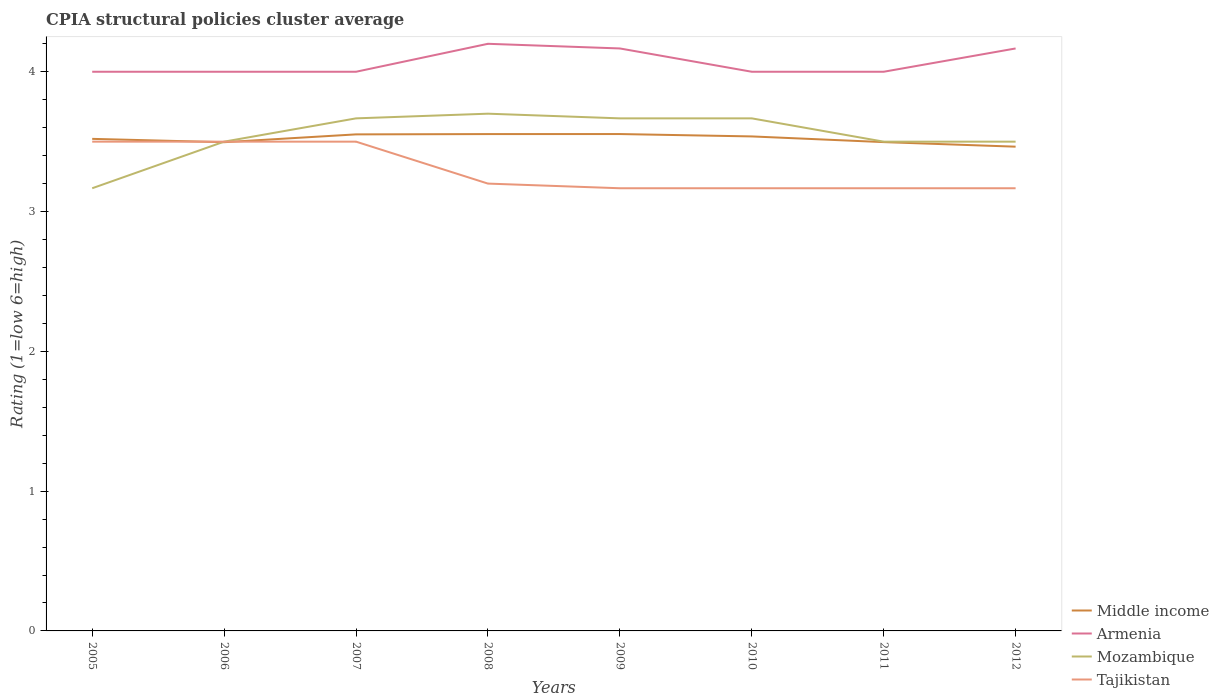Does the line corresponding to Middle income intersect with the line corresponding to Tajikistan?
Provide a short and direct response. Yes. Across all years, what is the maximum CPIA rating in Tajikistan?
Provide a short and direct response. 3.17. In which year was the CPIA rating in Tajikistan maximum?
Ensure brevity in your answer.  2009. What is the total CPIA rating in Tajikistan in the graph?
Offer a very short reply. 0.33. What is the difference between the highest and the second highest CPIA rating in Tajikistan?
Keep it short and to the point. 0.33. What is the difference between the highest and the lowest CPIA rating in Tajikistan?
Make the answer very short. 3. Is the CPIA rating in Tajikistan strictly greater than the CPIA rating in Armenia over the years?
Give a very brief answer. Yes. What is the difference between two consecutive major ticks on the Y-axis?
Provide a short and direct response. 1. Does the graph contain any zero values?
Your response must be concise. No. Does the graph contain grids?
Ensure brevity in your answer.  No. How are the legend labels stacked?
Provide a short and direct response. Vertical. What is the title of the graph?
Offer a very short reply. CPIA structural policies cluster average. What is the label or title of the Y-axis?
Your response must be concise. Rating (1=low 6=high). What is the Rating (1=low 6=high) of Middle income in 2005?
Provide a short and direct response. 3.52. What is the Rating (1=low 6=high) in Mozambique in 2005?
Ensure brevity in your answer.  3.17. What is the Rating (1=low 6=high) in Middle income in 2006?
Your answer should be compact. 3.5. What is the Rating (1=low 6=high) of Mozambique in 2006?
Keep it short and to the point. 3.5. What is the Rating (1=low 6=high) in Tajikistan in 2006?
Provide a succinct answer. 3.5. What is the Rating (1=low 6=high) of Middle income in 2007?
Make the answer very short. 3.55. What is the Rating (1=low 6=high) in Mozambique in 2007?
Keep it short and to the point. 3.67. What is the Rating (1=low 6=high) of Tajikistan in 2007?
Ensure brevity in your answer.  3.5. What is the Rating (1=low 6=high) of Middle income in 2008?
Keep it short and to the point. 3.55. What is the Rating (1=low 6=high) of Armenia in 2008?
Your answer should be compact. 4.2. What is the Rating (1=low 6=high) of Mozambique in 2008?
Offer a terse response. 3.7. What is the Rating (1=low 6=high) in Middle income in 2009?
Offer a terse response. 3.55. What is the Rating (1=low 6=high) in Armenia in 2009?
Make the answer very short. 4.17. What is the Rating (1=low 6=high) in Mozambique in 2009?
Your answer should be compact. 3.67. What is the Rating (1=low 6=high) in Tajikistan in 2009?
Your answer should be very brief. 3.17. What is the Rating (1=low 6=high) of Middle income in 2010?
Offer a terse response. 3.54. What is the Rating (1=low 6=high) in Armenia in 2010?
Your answer should be very brief. 4. What is the Rating (1=low 6=high) of Mozambique in 2010?
Ensure brevity in your answer.  3.67. What is the Rating (1=low 6=high) in Tajikistan in 2010?
Offer a very short reply. 3.17. What is the Rating (1=low 6=high) in Middle income in 2011?
Your response must be concise. 3.5. What is the Rating (1=low 6=high) of Tajikistan in 2011?
Your answer should be compact. 3.17. What is the Rating (1=low 6=high) in Middle income in 2012?
Provide a short and direct response. 3.46. What is the Rating (1=low 6=high) of Armenia in 2012?
Provide a short and direct response. 4.17. What is the Rating (1=low 6=high) of Mozambique in 2012?
Provide a succinct answer. 3.5. What is the Rating (1=low 6=high) of Tajikistan in 2012?
Keep it short and to the point. 3.17. Across all years, what is the maximum Rating (1=low 6=high) in Middle income?
Your answer should be compact. 3.55. Across all years, what is the maximum Rating (1=low 6=high) of Armenia?
Your response must be concise. 4.2. Across all years, what is the minimum Rating (1=low 6=high) of Middle income?
Your answer should be very brief. 3.46. Across all years, what is the minimum Rating (1=low 6=high) in Armenia?
Ensure brevity in your answer.  4. Across all years, what is the minimum Rating (1=low 6=high) in Mozambique?
Your answer should be very brief. 3.17. Across all years, what is the minimum Rating (1=low 6=high) of Tajikistan?
Provide a succinct answer. 3.17. What is the total Rating (1=low 6=high) of Middle income in the graph?
Ensure brevity in your answer.  28.17. What is the total Rating (1=low 6=high) of Armenia in the graph?
Offer a terse response. 32.53. What is the total Rating (1=low 6=high) of Mozambique in the graph?
Give a very brief answer. 28.37. What is the total Rating (1=low 6=high) in Tajikistan in the graph?
Your response must be concise. 26.37. What is the difference between the Rating (1=low 6=high) of Middle income in 2005 and that in 2006?
Your answer should be very brief. 0.02. What is the difference between the Rating (1=low 6=high) in Mozambique in 2005 and that in 2006?
Make the answer very short. -0.33. What is the difference between the Rating (1=low 6=high) in Middle income in 2005 and that in 2007?
Make the answer very short. -0.03. What is the difference between the Rating (1=low 6=high) of Middle income in 2005 and that in 2008?
Your answer should be very brief. -0.03. What is the difference between the Rating (1=low 6=high) in Mozambique in 2005 and that in 2008?
Keep it short and to the point. -0.53. What is the difference between the Rating (1=low 6=high) of Tajikistan in 2005 and that in 2008?
Offer a terse response. 0.3. What is the difference between the Rating (1=low 6=high) in Middle income in 2005 and that in 2009?
Keep it short and to the point. -0.03. What is the difference between the Rating (1=low 6=high) in Armenia in 2005 and that in 2009?
Provide a succinct answer. -0.17. What is the difference between the Rating (1=low 6=high) of Mozambique in 2005 and that in 2009?
Offer a terse response. -0.5. What is the difference between the Rating (1=low 6=high) of Tajikistan in 2005 and that in 2009?
Offer a terse response. 0.33. What is the difference between the Rating (1=low 6=high) in Middle income in 2005 and that in 2010?
Ensure brevity in your answer.  -0.02. What is the difference between the Rating (1=low 6=high) in Armenia in 2005 and that in 2010?
Offer a very short reply. 0. What is the difference between the Rating (1=low 6=high) of Tajikistan in 2005 and that in 2010?
Provide a succinct answer. 0.33. What is the difference between the Rating (1=low 6=high) in Middle income in 2005 and that in 2011?
Provide a short and direct response. 0.02. What is the difference between the Rating (1=low 6=high) of Mozambique in 2005 and that in 2011?
Offer a terse response. -0.33. What is the difference between the Rating (1=low 6=high) of Middle income in 2005 and that in 2012?
Your response must be concise. 0.06. What is the difference between the Rating (1=low 6=high) of Middle income in 2006 and that in 2007?
Your response must be concise. -0.06. What is the difference between the Rating (1=low 6=high) of Armenia in 2006 and that in 2007?
Your response must be concise. 0. What is the difference between the Rating (1=low 6=high) in Middle income in 2006 and that in 2008?
Provide a short and direct response. -0.06. What is the difference between the Rating (1=low 6=high) of Armenia in 2006 and that in 2008?
Provide a short and direct response. -0.2. What is the difference between the Rating (1=low 6=high) in Mozambique in 2006 and that in 2008?
Ensure brevity in your answer.  -0.2. What is the difference between the Rating (1=low 6=high) of Tajikistan in 2006 and that in 2008?
Your response must be concise. 0.3. What is the difference between the Rating (1=low 6=high) in Middle income in 2006 and that in 2009?
Keep it short and to the point. -0.06. What is the difference between the Rating (1=low 6=high) of Armenia in 2006 and that in 2009?
Offer a terse response. -0.17. What is the difference between the Rating (1=low 6=high) of Mozambique in 2006 and that in 2009?
Provide a succinct answer. -0.17. What is the difference between the Rating (1=low 6=high) in Middle income in 2006 and that in 2010?
Provide a short and direct response. -0.04. What is the difference between the Rating (1=low 6=high) of Armenia in 2006 and that in 2010?
Provide a succinct answer. 0. What is the difference between the Rating (1=low 6=high) of Tajikistan in 2006 and that in 2010?
Provide a succinct answer. 0.33. What is the difference between the Rating (1=low 6=high) in Middle income in 2006 and that in 2011?
Offer a very short reply. -0. What is the difference between the Rating (1=low 6=high) of Middle income in 2006 and that in 2012?
Give a very brief answer. 0.03. What is the difference between the Rating (1=low 6=high) of Armenia in 2006 and that in 2012?
Your answer should be compact. -0.17. What is the difference between the Rating (1=low 6=high) of Mozambique in 2006 and that in 2012?
Your answer should be compact. 0. What is the difference between the Rating (1=low 6=high) of Tajikistan in 2006 and that in 2012?
Your response must be concise. 0.33. What is the difference between the Rating (1=low 6=high) in Middle income in 2007 and that in 2008?
Make the answer very short. -0. What is the difference between the Rating (1=low 6=high) of Armenia in 2007 and that in 2008?
Keep it short and to the point. -0.2. What is the difference between the Rating (1=low 6=high) in Mozambique in 2007 and that in 2008?
Make the answer very short. -0.03. What is the difference between the Rating (1=low 6=high) in Tajikistan in 2007 and that in 2008?
Your answer should be very brief. 0.3. What is the difference between the Rating (1=low 6=high) of Middle income in 2007 and that in 2009?
Make the answer very short. -0. What is the difference between the Rating (1=low 6=high) in Armenia in 2007 and that in 2009?
Your response must be concise. -0.17. What is the difference between the Rating (1=low 6=high) of Tajikistan in 2007 and that in 2009?
Ensure brevity in your answer.  0.33. What is the difference between the Rating (1=low 6=high) of Middle income in 2007 and that in 2010?
Your answer should be compact. 0.01. What is the difference between the Rating (1=low 6=high) in Armenia in 2007 and that in 2010?
Give a very brief answer. 0. What is the difference between the Rating (1=low 6=high) of Mozambique in 2007 and that in 2010?
Your answer should be very brief. 0. What is the difference between the Rating (1=low 6=high) in Middle income in 2007 and that in 2011?
Offer a very short reply. 0.06. What is the difference between the Rating (1=low 6=high) in Tajikistan in 2007 and that in 2011?
Make the answer very short. 0.33. What is the difference between the Rating (1=low 6=high) of Middle income in 2007 and that in 2012?
Your response must be concise. 0.09. What is the difference between the Rating (1=low 6=high) in Armenia in 2007 and that in 2012?
Your response must be concise. -0.17. What is the difference between the Rating (1=low 6=high) of Tajikistan in 2007 and that in 2012?
Ensure brevity in your answer.  0.33. What is the difference between the Rating (1=low 6=high) in Middle income in 2008 and that in 2009?
Give a very brief answer. -0. What is the difference between the Rating (1=low 6=high) in Armenia in 2008 and that in 2009?
Make the answer very short. 0.03. What is the difference between the Rating (1=low 6=high) in Mozambique in 2008 and that in 2009?
Ensure brevity in your answer.  0.03. What is the difference between the Rating (1=low 6=high) of Middle income in 2008 and that in 2010?
Provide a short and direct response. 0.02. What is the difference between the Rating (1=low 6=high) of Armenia in 2008 and that in 2010?
Offer a very short reply. 0.2. What is the difference between the Rating (1=low 6=high) of Mozambique in 2008 and that in 2010?
Offer a very short reply. 0.03. What is the difference between the Rating (1=low 6=high) of Middle income in 2008 and that in 2011?
Provide a short and direct response. 0.06. What is the difference between the Rating (1=low 6=high) in Middle income in 2008 and that in 2012?
Give a very brief answer. 0.09. What is the difference between the Rating (1=low 6=high) of Tajikistan in 2008 and that in 2012?
Provide a succinct answer. 0.03. What is the difference between the Rating (1=low 6=high) in Middle income in 2009 and that in 2010?
Keep it short and to the point. 0.02. What is the difference between the Rating (1=low 6=high) of Mozambique in 2009 and that in 2010?
Give a very brief answer. 0. What is the difference between the Rating (1=low 6=high) in Middle income in 2009 and that in 2011?
Make the answer very short. 0.06. What is the difference between the Rating (1=low 6=high) in Mozambique in 2009 and that in 2011?
Keep it short and to the point. 0.17. What is the difference between the Rating (1=low 6=high) in Tajikistan in 2009 and that in 2011?
Your answer should be compact. 0. What is the difference between the Rating (1=low 6=high) in Middle income in 2009 and that in 2012?
Your response must be concise. 0.09. What is the difference between the Rating (1=low 6=high) of Armenia in 2009 and that in 2012?
Your answer should be very brief. 0. What is the difference between the Rating (1=low 6=high) of Tajikistan in 2009 and that in 2012?
Keep it short and to the point. 0. What is the difference between the Rating (1=low 6=high) of Middle income in 2010 and that in 2011?
Your response must be concise. 0.04. What is the difference between the Rating (1=low 6=high) of Armenia in 2010 and that in 2011?
Ensure brevity in your answer.  0. What is the difference between the Rating (1=low 6=high) of Mozambique in 2010 and that in 2011?
Make the answer very short. 0.17. What is the difference between the Rating (1=low 6=high) of Tajikistan in 2010 and that in 2011?
Give a very brief answer. 0. What is the difference between the Rating (1=low 6=high) of Middle income in 2010 and that in 2012?
Your response must be concise. 0.07. What is the difference between the Rating (1=low 6=high) in Mozambique in 2010 and that in 2012?
Ensure brevity in your answer.  0.17. What is the difference between the Rating (1=low 6=high) in Middle income in 2011 and that in 2012?
Provide a short and direct response. 0.03. What is the difference between the Rating (1=low 6=high) in Tajikistan in 2011 and that in 2012?
Your response must be concise. 0. What is the difference between the Rating (1=low 6=high) of Middle income in 2005 and the Rating (1=low 6=high) of Armenia in 2006?
Give a very brief answer. -0.48. What is the difference between the Rating (1=low 6=high) of Middle income in 2005 and the Rating (1=low 6=high) of Mozambique in 2006?
Make the answer very short. 0.02. What is the difference between the Rating (1=low 6=high) in Middle income in 2005 and the Rating (1=low 6=high) in Tajikistan in 2006?
Provide a short and direct response. 0.02. What is the difference between the Rating (1=low 6=high) in Armenia in 2005 and the Rating (1=low 6=high) in Mozambique in 2006?
Your answer should be compact. 0.5. What is the difference between the Rating (1=low 6=high) in Middle income in 2005 and the Rating (1=low 6=high) in Armenia in 2007?
Provide a succinct answer. -0.48. What is the difference between the Rating (1=low 6=high) of Middle income in 2005 and the Rating (1=low 6=high) of Mozambique in 2007?
Offer a terse response. -0.15. What is the difference between the Rating (1=low 6=high) of Armenia in 2005 and the Rating (1=low 6=high) of Mozambique in 2007?
Provide a short and direct response. 0.33. What is the difference between the Rating (1=low 6=high) of Mozambique in 2005 and the Rating (1=low 6=high) of Tajikistan in 2007?
Provide a short and direct response. -0.33. What is the difference between the Rating (1=low 6=high) in Middle income in 2005 and the Rating (1=low 6=high) in Armenia in 2008?
Your response must be concise. -0.68. What is the difference between the Rating (1=low 6=high) of Middle income in 2005 and the Rating (1=low 6=high) of Mozambique in 2008?
Your answer should be very brief. -0.18. What is the difference between the Rating (1=low 6=high) of Middle income in 2005 and the Rating (1=low 6=high) of Tajikistan in 2008?
Offer a very short reply. 0.32. What is the difference between the Rating (1=low 6=high) in Armenia in 2005 and the Rating (1=low 6=high) in Mozambique in 2008?
Your answer should be compact. 0.3. What is the difference between the Rating (1=low 6=high) of Armenia in 2005 and the Rating (1=low 6=high) of Tajikistan in 2008?
Give a very brief answer. 0.8. What is the difference between the Rating (1=low 6=high) in Mozambique in 2005 and the Rating (1=low 6=high) in Tajikistan in 2008?
Provide a succinct answer. -0.03. What is the difference between the Rating (1=low 6=high) in Middle income in 2005 and the Rating (1=low 6=high) in Armenia in 2009?
Provide a short and direct response. -0.65. What is the difference between the Rating (1=low 6=high) in Middle income in 2005 and the Rating (1=low 6=high) in Mozambique in 2009?
Give a very brief answer. -0.15. What is the difference between the Rating (1=low 6=high) in Middle income in 2005 and the Rating (1=low 6=high) in Tajikistan in 2009?
Your response must be concise. 0.35. What is the difference between the Rating (1=low 6=high) in Armenia in 2005 and the Rating (1=low 6=high) in Mozambique in 2009?
Offer a terse response. 0.33. What is the difference between the Rating (1=low 6=high) of Middle income in 2005 and the Rating (1=low 6=high) of Armenia in 2010?
Your answer should be compact. -0.48. What is the difference between the Rating (1=low 6=high) of Middle income in 2005 and the Rating (1=low 6=high) of Mozambique in 2010?
Provide a succinct answer. -0.15. What is the difference between the Rating (1=low 6=high) of Middle income in 2005 and the Rating (1=low 6=high) of Tajikistan in 2010?
Your answer should be compact. 0.35. What is the difference between the Rating (1=low 6=high) of Armenia in 2005 and the Rating (1=low 6=high) of Mozambique in 2010?
Keep it short and to the point. 0.33. What is the difference between the Rating (1=low 6=high) in Armenia in 2005 and the Rating (1=low 6=high) in Tajikistan in 2010?
Keep it short and to the point. 0.83. What is the difference between the Rating (1=low 6=high) of Middle income in 2005 and the Rating (1=low 6=high) of Armenia in 2011?
Provide a short and direct response. -0.48. What is the difference between the Rating (1=low 6=high) in Middle income in 2005 and the Rating (1=low 6=high) in Tajikistan in 2011?
Ensure brevity in your answer.  0.35. What is the difference between the Rating (1=low 6=high) in Mozambique in 2005 and the Rating (1=low 6=high) in Tajikistan in 2011?
Provide a short and direct response. 0. What is the difference between the Rating (1=low 6=high) in Middle income in 2005 and the Rating (1=low 6=high) in Armenia in 2012?
Your answer should be very brief. -0.65. What is the difference between the Rating (1=low 6=high) in Middle income in 2005 and the Rating (1=low 6=high) in Mozambique in 2012?
Ensure brevity in your answer.  0.02. What is the difference between the Rating (1=low 6=high) of Middle income in 2005 and the Rating (1=low 6=high) of Tajikistan in 2012?
Make the answer very short. 0.35. What is the difference between the Rating (1=low 6=high) in Armenia in 2005 and the Rating (1=low 6=high) in Tajikistan in 2012?
Give a very brief answer. 0.83. What is the difference between the Rating (1=low 6=high) in Middle income in 2006 and the Rating (1=low 6=high) in Armenia in 2007?
Make the answer very short. -0.5. What is the difference between the Rating (1=low 6=high) of Middle income in 2006 and the Rating (1=low 6=high) of Mozambique in 2007?
Offer a very short reply. -0.17. What is the difference between the Rating (1=low 6=high) in Middle income in 2006 and the Rating (1=low 6=high) in Tajikistan in 2007?
Offer a terse response. -0. What is the difference between the Rating (1=low 6=high) of Mozambique in 2006 and the Rating (1=low 6=high) of Tajikistan in 2007?
Offer a very short reply. 0. What is the difference between the Rating (1=low 6=high) in Middle income in 2006 and the Rating (1=low 6=high) in Armenia in 2008?
Provide a short and direct response. -0.7. What is the difference between the Rating (1=low 6=high) in Middle income in 2006 and the Rating (1=low 6=high) in Mozambique in 2008?
Offer a very short reply. -0.2. What is the difference between the Rating (1=low 6=high) in Middle income in 2006 and the Rating (1=low 6=high) in Tajikistan in 2008?
Your answer should be very brief. 0.3. What is the difference between the Rating (1=low 6=high) in Armenia in 2006 and the Rating (1=low 6=high) in Tajikistan in 2008?
Your answer should be compact. 0.8. What is the difference between the Rating (1=low 6=high) in Middle income in 2006 and the Rating (1=low 6=high) in Armenia in 2009?
Your response must be concise. -0.67. What is the difference between the Rating (1=low 6=high) in Middle income in 2006 and the Rating (1=low 6=high) in Mozambique in 2009?
Your answer should be compact. -0.17. What is the difference between the Rating (1=low 6=high) of Middle income in 2006 and the Rating (1=low 6=high) of Tajikistan in 2009?
Give a very brief answer. 0.33. What is the difference between the Rating (1=low 6=high) in Middle income in 2006 and the Rating (1=low 6=high) in Armenia in 2010?
Give a very brief answer. -0.5. What is the difference between the Rating (1=low 6=high) in Middle income in 2006 and the Rating (1=low 6=high) in Mozambique in 2010?
Offer a terse response. -0.17. What is the difference between the Rating (1=low 6=high) in Middle income in 2006 and the Rating (1=low 6=high) in Tajikistan in 2010?
Your answer should be compact. 0.33. What is the difference between the Rating (1=low 6=high) in Armenia in 2006 and the Rating (1=low 6=high) in Mozambique in 2010?
Your response must be concise. 0.33. What is the difference between the Rating (1=low 6=high) of Mozambique in 2006 and the Rating (1=low 6=high) of Tajikistan in 2010?
Offer a terse response. 0.33. What is the difference between the Rating (1=low 6=high) of Middle income in 2006 and the Rating (1=low 6=high) of Armenia in 2011?
Your answer should be compact. -0.5. What is the difference between the Rating (1=low 6=high) in Middle income in 2006 and the Rating (1=low 6=high) in Mozambique in 2011?
Give a very brief answer. -0. What is the difference between the Rating (1=low 6=high) of Middle income in 2006 and the Rating (1=low 6=high) of Tajikistan in 2011?
Ensure brevity in your answer.  0.33. What is the difference between the Rating (1=low 6=high) of Armenia in 2006 and the Rating (1=low 6=high) of Mozambique in 2011?
Your response must be concise. 0.5. What is the difference between the Rating (1=low 6=high) in Mozambique in 2006 and the Rating (1=low 6=high) in Tajikistan in 2011?
Offer a terse response. 0.33. What is the difference between the Rating (1=low 6=high) in Middle income in 2006 and the Rating (1=low 6=high) in Armenia in 2012?
Make the answer very short. -0.67. What is the difference between the Rating (1=low 6=high) of Middle income in 2006 and the Rating (1=low 6=high) of Mozambique in 2012?
Provide a short and direct response. -0. What is the difference between the Rating (1=low 6=high) in Middle income in 2006 and the Rating (1=low 6=high) in Tajikistan in 2012?
Ensure brevity in your answer.  0.33. What is the difference between the Rating (1=low 6=high) in Armenia in 2006 and the Rating (1=low 6=high) in Mozambique in 2012?
Your response must be concise. 0.5. What is the difference between the Rating (1=low 6=high) in Armenia in 2006 and the Rating (1=low 6=high) in Tajikistan in 2012?
Offer a very short reply. 0.83. What is the difference between the Rating (1=low 6=high) of Middle income in 2007 and the Rating (1=low 6=high) of Armenia in 2008?
Provide a short and direct response. -0.65. What is the difference between the Rating (1=low 6=high) in Middle income in 2007 and the Rating (1=low 6=high) in Mozambique in 2008?
Make the answer very short. -0.15. What is the difference between the Rating (1=low 6=high) of Middle income in 2007 and the Rating (1=low 6=high) of Tajikistan in 2008?
Ensure brevity in your answer.  0.35. What is the difference between the Rating (1=low 6=high) in Armenia in 2007 and the Rating (1=low 6=high) in Tajikistan in 2008?
Your response must be concise. 0.8. What is the difference between the Rating (1=low 6=high) of Mozambique in 2007 and the Rating (1=low 6=high) of Tajikistan in 2008?
Your answer should be very brief. 0.47. What is the difference between the Rating (1=low 6=high) in Middle income in 2007 and the Rating (1=low 6=high) in Armenia in 2009?
Provide a succinct answer. -0.61. What is the difference between the Rating (1=low 6=high) of Middle income in 2007 and the Rating (1=low 6=high) of Mozambique in 2009?
Your answer should be very brief. -0.11. What is the difference between the Rating (1=low 6=high) of Middle income in 2007 and the Rating (1=low 6=high) of Tajikistan in 2009?
Your response must be concise. 0.39. What is the difference between the Rating (1=low 6=high) in Armenia in 2007 and the Rating (1=low 6=high) in Mozambique in 2009?
Make the answer very short. 0.33. What is the difference between the Rating (1=low 6=high) in Middle income in 2007 and the Rating (1=low 6=high) in Armenia in 2010?
Give a very brief answer. -0.45. What is the difference between the Rating (1=low 6=high) of Middle income in 2007 and the Rating (1=low 6=high) of Mozambique in 2010?
Give a very brief answer. -0.11. What is the difference between the Rating (1=low 6=high) of Middle income in 2007 and the Rating (1=low 6=high) of Tajikistan in 2010?
Offer a very short reply. 0.39. What is the difference between the Rating (1=low 6=high) in Middle income in 2007 and the Rating (1=low 6=high) in Armenia in 2011?
Keep it short and to the point. -0.45. What is the difference between the Rating (1=low 6=high) in Middle income in 2007 and the Rating (1=low 6=high) in Mozambique in 2011?
Your answer should be compact. 0.05. What is the difference between the Rating (1=low 6=high) of Middle income in 2007 and the Rating (1=low 6=high) of Tajikistan in 2011?
Keep it short and to the point. 0.39. What is the difference between the Rating (1=low 6=high) of Armenia in 2007 and the Rating (1=low 6=high) of Mozambique in 2011?
Give a very brief answer. 0.5. What is the difference between the Rating (1=low 6=high) in Middle income in 2007 and the Rating (1=low 6=high) in Armenia in 2012?
Your answer should be very brief. -0.61. What is the difference between the Rating (1=low 6=high) of Middle income in 2007 and the Rating (1=low 6=high) of Mozambique in 2012?
Offer a very short reply. 0.05. What is the difference between the Rating (1=low 6=high) of Middle income in 2007 and the Rating (1=low 6=high) of Tajikistan in 2012?
Keep it short and to the point. 0.39. What is the difference between the Rating (1=low 6=high) in Mozambique in 2007 and the Rating (1=low 6=high) in Tajikistan in 2012?
Provide a short and direct response. 0.5. What is the difference between the Rating (1=low 6=high) in Middle income in 2008 and the Rating (1=low 6=high) in Armenia in 2009?
Give a very brief answer. -0.61. What is the difference between the Rating (1=low 6=high) of Middle income in 2008 and the Rating (1=low 6=high) of Mozambique in 2009?
Your response must be concise. -0.11. What is the difference between the Rating (1=low 6=high) of Middle income in 2008 and the Rating (1=low 6=high) of Tajikistan in 2009?
Offer a terse response. 0.39. What is the difference between the Rating (1=low 6=high) in Armenia in 2008 and the Rating (1=low 6=high) in Mozambique in 2009?
Your answer should be compact. 0.53. What is the difference between the Rating (1=low 6=high) in Mozambique in 2008 and the Rating (1=low 6=high) in Tajikistan in 2009?
Your response must be concise. 0.53. What is the difference between the Rating (1=low 6=high) of Middle income in 2008 and the Rating (1=low 6=high) of Armenia in 2010?
Ensure brevity in your answer.  -0.45. What is the difference between the Rating (1=low 6=high) in Middle income in 2008 and the Rating (1=low 6=high) in Mozambique in 2010?
Make the answer very short. -0.11. What is the difference between the Rating (1=low 6=high) in Middle income in 2008 and the Rating (1=low 6=high) in Tajikistan in 2010?
Your answer should be compact. 0.39. What is the difference between the Rating (1=low 6=high) in Armenia in 2008 and the Rating (1=low 6=high) in Mozambique in 2010?
Make the answer very short. 0.53. What is the difference between the Rating (1=low 6=high) of Armenia in 2008 and the Rating (1=low 6=high) of Tajikistan in 2010?
Your answer should be compact. 1.03. What is the difference between the Rating (1=low 6=high) of Mozambique in 2008 and the Rating (1=low 6=high) of Tajikistan in 2010?
Give a very brief answer. 0.53. What is the difference between the Rating (1=low 6=high) in Middle income in 2008 and the Rating (1=low 6=high) in Armenia in 2011?
Provide a succinct answer. -0.45. What is the difference between the Rating (1=low 6=high) in Middle income in 2008 and the Rating (1=low 6=high) in Mozambique in 2011?
Offer a terse response. 0.05. What is the difference between the Rating (1=low 6=high) of Middle income in 2008 and the Rating (1=low 6=high) of Tajikistan in 2011?
Provide a succinct answer. 0.39. What is the difference between the Rating (1=low 6=high) of Mozambique in 2008 and the Rating (1=low 6=high) of Tajikistan in 2011?
Your response must be concise. 0.53. What is the difference between the Rating (1=low 6=high) in Middle income in 2008 and the Rating (1=low 6=high) in Armenia in 2012?
Your answer should be compact. -0.61. What is the difference between the Rating (1=low 6=high) in Middle income in 2008 and the Rating (1=low 6=high) in Mozambique in 2012?
Keep it short and to the point. 0.05. What is the difference between the Rating (1=low 6=high) of Middle income in 2008 and the Rating (1=low 6=high) of Tajikistan in 2012?
Your answer should be very brief. 0.39. What is the difference between the Rating (1=low 6=high) of Armenia in 2008 and the Rating (1=low 6=high) of Mozambique in 2012?
Offer a terse response. 0.7. What is the difference between the Rating (1=low 6=high) of Armenia in 2008 and the Rating (1=low 6=high) of Tajikistan in 2012?
Offer a very short reply. 1.03. What is the difference between the Rating (1=low 6=high) of Mozambique in 2008 and the Rating (1=low 6=high) of Tajikistan in 2012?
Your answer should be compact. 0.53. What is the difference between the Rating (1=low 6=high) of Middle income in 2009 and the Rating (1=low 6=high) of Armenia in 2010?
Your answer should be very brief. -0.45. What is the difference between the Rating (1=low 6=high) of Middle income in 2009 and the Rating (1=low 6=high) of Mozambique in 2010?
Provide a succinct answer. -0.11. What is the difference between the Rating (1=low 6=high) in Middle income in 2009 and the Rating (1=low 6=high) in Tajikistan in 2010?
Provide a short and direct response. 0.39. What is the difference between the Rating (1=low 6=high) in Armenia in 2009 and the Rating (1=low 6=high) in Tajikistan in 2010?
Give a very brief answer. 1. What is the difference between the Rating (1=low 6=high) in Mozambique in 2009 and the Rating (1=low 6=high) in Tajikistan in 2010?
Provide a succinct answer. 0.5. What is the difference between the Rating (1=low 6=high) in Middle income in 2009 and the Rating (1=low 6=high) in Armenia in 2011?
Make the answer very short. -0.45. What is the difference between the Rating (1=low 6=high) of Middle income in 2009 and the Rating (1=low 6=high) of Mozambique in 2011?
Give a very brief answer. 0.05. What is the difference between the Rating (1=low 6=high) of Middle income in 2009 and the Rating (1=low 6=high) of Tajikistan in 2011?
Keep it short and to the point. 0.39. What is the difference between the Rating (1=low 6=high) of Armenia in 2009 and the Rating (1=low 6=high) of Mozambique in 2011?
Keep it short and to the point. 0.67. What is the difference between the Rating (1=low 6=high) in Mozambique in 2009 and the Rating (1=low 6=high) in Tajikistan in 2011?
Ensure brevity in your answer.  0.5. What is the difference between the Rating (1=low 6=high) in Middle income in 2009 and the Rating (1=low 6=high) in Armenia in 2012?
Keep it short and to the point. -0.61. What is the difference between the Rating (1=low 6=high) in Middle income in 2009 and the Rating (1=low 6=high) in Mozambique in 2012?
Ensure brevity in your answer.  0.05. What is the difference between the Rating (1=low 6=high) in Middle income in 2009 and the Rating (1=low 6=high) in Tajikistan in 2012?
Make the answer very short. 0.39. What is the difference between the Rating (1=low 6=high) of Mozambique in 2009 and the Rating (1=low 6=high) of Tajikistan in 2012?
Give a very brief answer. 0.5. What is the difference between the Rating (1=low 6=high) in Middle income in 2010 and the Rating (1=low 6=high) in Armenia in 2011?
Provide a succinct answer. -0.46. What is the difference between the Rating (1=low 6=high) in Middle income in 2010 and the Rating (1=low 6=high) in Mozambique in 2011?
Your response must be concise. 0.04. What is the difference between the Rating (1=low 6=high) in Middle income in 2010 and the Rating (1=low 6=high) in Tajikistan in 2011?
Your answer should be compact. 0.37. What is the difference between the Rating (1=low 6=high) of Mozambique in 2010 and the Rating (1=low 6=high) of Tajikistan in 2011?
Provide a short and direct response. 0.5. What is the difference between the Rating (1=low 6=high) in Middle income in 2010 and the Rating (1=low 6=high) in Armenia in 2012?
Keep it short and to the point. -0.63. What is the difference between the Rating (1=low 6=high) of Middle income in 2010 and the Rating (1=low 6=high) of Mozambique in 2012?
Provide a succinct answer. 0.04. What is the difference between the Rating (1=low 6=high) of Middle income in 2010 and the Rating (1=low 6=high) of Tajikistan in 2012?
Give a very brief answer. 0.37. What is the difference between the Rating (1=low 6=high) in Armenia in 2010 and the Rating (1=low 6=high) in Tajikistan in 2012?
Your answer should be very brief. 0.83. What is the difference between the Rating (1=low 6=high) of Mozambique in 2010 and the Rating (1=low 6=high) of Tajikistan in 2012?
Your response must be concise. 0.5. What is the difference between the Rating (1=low 6=high) of Middle income in 2011 and the Rating (1=low 6=high) of Armenia in 2012?
Make the answer very short. -0.67. What is the difference between the Rating (1=low 6=high) in Middle income in 2011 and the Rating (1=low 6=high) in Mozambique in 2012?
Your response must be concise. -0. What is the difference between the Rating (1=low 6=high) in Middle income in 2011 and the Rating (1=low 6=high) in Tajikistan in 2012?
Your answer should be compact. 0.33. What is the difference between the Rating (1=low 6=high) of Armenia in 2011 and the Rating (1=low 6=high) of Mozambique in 2012?
Provide a short and direct response. 0.5. What is the difference between the Rating (1=low 6=high) of Mozambique in 2011 and the Rating (1=low 6=high) of Tajikistan in 2012?
Offer a very short reply. 0.33. What is the average Rating (1=low 6=high) in Middle income per year?
Provide a succinct answer. 3.52. What is the average Rating (1=low 6=high) in Armenia per year?
Ensure brevity in your answer.  4.07. What is the average Rating (1=low 6=high) of Mozambique per year?
Provide a succinct answer. 3.55. What is the average Rating (1=low 6=high) of Tajikistan per year?
Offer a terse response. 3.3. In the year 2005, what is the difference between the Rating (1=low 6=high) in Middle income and Rating (1=low 6=high) in Armenia?
Offer a very short reply. -0.48. In the year 2005, what is the difference between the Rating (1=low 6=high) in Middle income and Rating (1=low 6=high) in Mozambique?
Offer a terse response. 0.35. In the year 2005, what is the difference between the Rating (1=low 6=high) in Middle income and Rating (1=low 6=high) in Tajikistan?
Your response must be concise. 0.02. In the year 2005, what is the difference between the Rating (1=low 6=high) of Armenia and Rating (1=low 6=high) of Tajikistan?
Provide a succinct answer. 0.5. In the year 2006, what is the difference between the Rating (1=low 6=high) in Middle income and Rating (1=low 6=high) in Armenia?
Offer a very short reply. -0.5. In the year 2006, what is the difference between the Rating (1=low 6=high) in Middle income and Rating (1=low 6=high) in Mozambique?
Provide a short and direct response. -0. In the year 2006, what is the difference between the Rating (1=low 6=high) in Middle income and Rating (1=low 6=high) in Tajikistan?
Ensure brevity in your answer.  -0. In the year 2006, what is the difference between the Rating (1=low 6=high) of Armenia and Rating (1=low 6=high) of Tajikistan?
Provide a short and direct response. 0.5. In the year 2006, what is the difference between the Rating (1=low 6=high) of Mozambique and Rating (1=low 6=high) of Tajikistan?
Offer a very short reply. 0. In the year 2007, what is the difference between the Rating (1=low 6=high) in Middle income and Rating (1=low 6=high) in Armenia?
Ensure brevity in your answer.  -0.45. In the year 2007, what is the difference between the Rating (1=low 6=high) of Middle income and Rating (1=low 6=high) of Mozambique?
Keep it short and to the point. -0.11. In the year 2007, what is the difference between the Rating (1=low 6=high) in Middle income and Rating (1=low 6=high) in Tajikistan?
Provide a short and direct response. 0.05. In the year 2007, what is the difference between the Rating (1=low 6=high) in Armenia and Rating (1=low 6=high) in Tajikistan?
Keep it short and to the point. 0.5. In the year 2008, what is the difference between the Rating (1=low 6=high) in Middle income and Rating (1=low 6=high) in Armenia?
Ensure brevity in your answer.  -0.65. In the year 2008, what is the difference between the Rating (1=low 6=high) of Middle income and Rating (1=low 6=high) of Mozambique?
Give a very brief answer. -0.15. In the year 2008, what is the difference between the Rating (1=low 6=high) in Middle income and Rating (1=low 6=high) in Tajikistan?
Offer a terse response. 0.35. In the year 2008, what is the difference between the Rating (1=low 6=high) in Mozambique and Rating (1=low 6=high) in Tajikistan?
Make the answer very short. 0.5. In the year 2009, what is the difference between the Rating (1=low 6=high) of Middle income and Rating (1=low 6=high) of Armenia?
Keep it short and to the point. -0.61. In the year 2009, what is the difference between the Rating (1=low 6=high) of Middle income and Rating (1=low 6=high) of Mozambique?
Your answer should be very brief. -0.11. In the year 2009, what is the difference between the Rating (1=low 6=high) of Middle income and Rating (1=low 6=high) of Tajikistan?
Make the answer very short. 0.39. In the year 2009, what is the difference between the Rating (1=low 6=high) in Armenia and Rating (1=low 6=high) in Tajikistan?
Provide a succinct answer. 1. In the year 2009, what is the difference between the Rating (1=low 6=high) in Mozambique and Rating (1=low 6=high) in Tajikistan?
Ensure brevity in your answer.  0.5. In the year 2010, what is the difference between the Rating (1=low 6=high) of Middle income and Rating (1=low 6=high) of Armenia?
Offer a very short reply. -0.46. In the year 2010, what is the difference between the Rating (1=low 6=high) of Middle income and Rating (1=low 6=high) of Mozambique?
Provide a short and direct response. -0.13. In the year 2010, what is the difference between the Rating (1=low 6=high) of Middle income and Rating (1=low 6=high) of Tajikistan?
Provide a short and direct response. 0.37. In the year 2010, what is the difference between the Rating (1=low 6=high) in Armenia and Rating (1=low 6=high) in Tajikistan?
Provide a short and direct response. 0.83. In the year 2010, what is the difference between the Rating (1=low 6=high) of Mozambique and Rating (1=low 6=high) of Tajikistan?
Keep it short and to the point. 0.5. In the year 2011, what is the difference between the Rating (1=low 6=high) of Middle income and Rating (1=low 6=high) of Armenia?
Keep it short and to the point. -0.5. In the year 2011, what is the difference between the Rating (1=low 6=high) in Middle income and Rating (1=low 6=high) in Mozambique?
Keep it short and to the point. -0. In the year 2011, what is the difference between the Rating (1=low 6=high) of Middle income and Rating (1=low 6=high) of Tajikistan?
Provide a succinct answer. 0.33. In the year 2011, what is the difference between the Rating (1=low 6=high) in Armenia and Rating (1=low 6=high) in Mozambique?
Provide a succinct answer. 0.5. In the year 2012, what is the difference between the Rating (1=low 6=high) in Middle income and Rating (1=low 6=high) in Armenia?
Your response must be concise. -0.7. In the year 2012, what is the difference between the Rating (1=low 6=high) in Middle income and Rating (1=low 6=high) in Mozambique?
Offer a very short reply. -0.04. In the year 2012, what is the difference between the Rating (1=low 6=high) of Middle income and Rating (1=low 6=high) of Tajikistan?
Ensure brevity in your answer.  0.3. In the year 2012, what is the difference between the Rating (1=low 6=high) of Armenia and Rating (1=low 6=high) of Mozambique?
Your response must be concise. 0.67. In the year 2012, what is the difference between the Rating (1=low 6=high) in Armenia and Rating (1=low 6=high) in Tajikistan?
Make the answer very short. 1. In the year 2012, what is the difference between the Rating (1=low 6=high) of Mozambique and Rating (1=low 6=high) of Tajikistan?
Your answer should be very brief. 0.33. What is the ratio of the Rating (1=low 6=high) in Middle income in 2005 to that in 2006?
Make the answer very short. 1.01. What is the ratio of the Rating (1=low 6=high) in Armenia in 2005 to that in 2006?
Keep it short and to the point. 1. What is the ratio of the Rating (1=low 6=high) of Mozambique in 2005 to that in 2006?
Your answer should be very brief. 0.9. What is the ratio of the Rating (1=low 6=high) in Tajikistan in 2005 to that in 2006?
Give a very brief answer. 1. What is the ratio of the Rating (1=low 6=high) in Armenia in 2005 to that in 2007?
Ensure brevity in your answer.  1. What is the ratio of the Rating (1=low 6=high) of Mozambique in 2005 to that in 2007?
Your response must be concise. 0.86. What is the ratio of the Rating (1=low 6=high) in Middle income in 2005 to that in 2008?
Your response must be concise. 0.99. What is the ratio of the Rating (1=low 6=high) of Armenia in 2005 to that in 2008?
Offer a very short reply. 0.95. What is the ratio of the Rating (1=low 6=high) in Mozambique in 2005 to that in 2008?
Provide a short and direct response. 0.86. What is the ratio of the Rating (1=low 6=high) in Tajikistan in 2005 to that in 2008?
Give a very brief answer. 1.09. What is the ratio of the Rating (1=low 6=high) of Middle income in 2005 to that in 2009?
Your response must be concise. 0.99. What is the ratio of the Rating (1=low 6=high) in Mozambique in 2005 to that in 2009?
Make the answer very short. 0.86. What is the ratio of the Rating (1=low 6=high) of Tajikistan in 2005 to that in 2009?
Your response must be concise. 1.11. What is the ratio of the Rating (1=low 6=high) of Mozambique in 2005 to that in 2010?
Ensure brevity in your answer.  0.86. What is the ratio of the Rating (1=low 6=high) in Tajikistan in 2005 to that in 2010?
Provide a short and direct response. 1.11. What is the ratio of the Rating (1=low 6=high) in Middle income in 2005 to that in 2011?
Offer a terse response. 1.01. What is the ratio of the Rating (1=low 6=high) in Mozambique in 2005 to that in 2011?
Ensure brevity in your answer.  0.9. What is the ratio of the Rating (1=low 6=high) of Tajikistan in 2005 to that in 2011?
Your answer should be compact. 1.11. What is the ratio of the Rating (1=low 6=high) of Middle income in 2005 to that in 2012?
Provide a succinct answer. 1.02. What is the ratio of the Rating (1=low 6=high) in Mozambique in 2005 to that in 2012?
Your answer should be compact. 0.9. What is the ratio of the Rating (1=low 6=high) in Tajikistan in 2005 to that in 2012?
Offer a very short reply. 1.11. What is the ratio of the Rating (1=low 6=high) in Middle income in 2006 to that in 2007?
Offer a terse response. 0.98. What is the ratio of the Rating (1=low 6=high) of Mozambique in 2006 to that in 2007?
Your answer should be compact. 0.95. What is the ratio of the Rating (1=low 6=high) in Middle income in 2006 to that in 2008?
Make the answer very short. 0.98. What is the ratio of the Rating (1=low 6=high) in Armenia in 2006 to that in 2008?
Provide a succinct answer. 0.95. What is the ratio of the Rating (1=low 6=high) in Mozambique in 2006 to that in 2008?
Your response must be concise. 0.95. What is the ratio of the Rating (1=low 6=high) of Tajikistan in 2006 to that in 2008?
Offer a very short reply. 1.09. What is the ratio of the Rating (1=low 6=high) of Middle income in 2006 to that in 2009?
Your answer should be compact. 0.98. What is the ratio of the Rating (1=low 6=high) in Armenia in 2006 to that in 2009?
Your answer should be compact. 0.96. What is the ratio of the Rating (1=low 6=high) in Mozambique in 2006 to that in 2009?
Your answer should be very brief. 0.95. What is the ratio of the Rating (1=low 6=high) in Tajikistan in 2006 to that in 2009?
Offer a very short reply. 1.11. What is the ratio of the Rating (1=low 6=high) in Middle income in 2006 to that in 2010?
Your answer should be compact. 0.99. What is the ratio of the Rating (1=low 6=high) in Mozambique in 2006 to that in 2010?
Your response must be concise. 0.95. What is the ratio of the Rating (1=low 6=high) in Tajikistan in 2006 to that in 2010?
Make the answer very short. 1.11. What is the ratio of the Rating (1=low 6=high) of Middle income in 2006 to that in 2011?
Provide a short and direct response. 1. What is the ratio of the Rating (1=low 6=high) in Armenia in 2006 to that in 2011?
Give a very brief answer. 1. What is the ratio of the Rating (1=low 6=high) in Mozambique in 2006 to that in 2011?
Keep it short and to the point. 1. What is the ratio of the Rating (1=low 6=high) in Tajikistan in 2006 to that in 2011?
Keep it short and to the point. 1.11. What is the ratio of the Rating (1=low 6=high) of Middle income in 2006 to that in 2012?
Give a very brief answer. 1.01. What is the ratio of the Rating (1=low 6=high) in Mozambique in 2006 to that in 2012?
Ensure brevity in your answer.  1. What is the ratio of the Rating (1=low 6=high) in Tajikistan in 2006 to that in 2012?
Ensure brevity in your answer.  1.11. What is the ratio of the Rating (1=low 6=high) in Middle income in 2007 to that in 2008?
Give a very brief answer. 1. What is the ratio of the Rating (1=low 6=high) in Tajikistan in 2007 to that in 2008?
Provide a succinct answer. 1.09. What is the ratio of the Rating (1=low 6=high) in Middle income in 2007 to that in 2009?
Make the answer very short. 1. What is the ratio of the Rating (1=low 6=high) of Mozambique in 2007 to that in 2009?
Provide a succinct answer. 1. What is the ratio of the Rating (1=low 6=high) in Tajikistan in 2007 to that in 2009?
Make the answer very short. 1.11. What is the ratio of the Rating (1=low 6=high) in Middle income in 2007 to that in 2010?
Your answer should be compact. 1. What is the ratio of the Rating (1=low 6=high) in Armenia in 2007 to that in 2010?
Ensure brevity in your answer.  1. What is the ratio of the Rating (1=low 6=high) of Tajikistan in 2007 to that in 2010?
Your answer should be very brief. 1.11. What is the ratio of the Rating (1=low 6=high) of Middle income in 2007 to that in 2011?
Ensure brevity in your answer.  1.02. What is the ratio of the Rating (1=low 6=high) in Armenia in 2007 to that in 2011?
Make the answer very short. 1. What is the ratio of the Rating (1=low 6=high) in Mozambique in 2007 to that in 2011?
Keep it short and to the point. 1.05. What is the ratio of the Rating (1=low 6=high) in Tajikistan in 2007 to that in 2011?
Offer a terse response. 1.11. What is the ratio of the Rating (1=low 6=high) of Middle income in 2007 to that in 2012?
Your answer should be compact. 1.03. What is the ratio of the Rating (1=low 6=high) in Armenia in 2007 to that in 2012?
Give a very brief answer. 0.96. What is the ratio of the Rating (1=low 6=high) in Mozambique in 2007 to that in 2012?
Offer a terse response. 1.05. What is the ratio of the Rating (1=low 6=high) of Tajikistan in 2007 to that in 2012?
Ensure brevity in your answer.  1.11. What is the ratio of the Rating (1=low 6=high) in Armenia in 2008 to that in 2009?
Keep it short and to the point. 1.01. What is the ratio of the Rating (1=low 6=high) of Mozambique in 2008 to that in 2009?
Your answer should be compact. 1.01. What is the ratio of the Rating (1=low 6=high) in Tajikistan in 2008 to that in 2009?
Your response must be concise. 1.01. What is the ratio of the Rating (1=low 6=high) of Middle income in 2008 to that in 2010?
Ensure brevity in your answer.  1. What is the ratio of the Rating (1=low 6=high) of Mozambique in 2008 to that in 2010?
Your answer should be compact. 1.01. What is the ratio of the Rating (1=low 6=high) of Tajikistan in 2008 to that in 2010?
Your answer should be very brief. 1.01. What is the ratio of the Rating (1=low 6=high) in Middle income in 2008 to that in 2011?
Offer a terse response. 1.02. What is the ratio of the Rating (1=low 6=high) in Armenia in 2008 to that in 2011?
Offer a terse response. 1.05. What is the ratio of the Rating (1=low 6=high) in Mozambique in 2008 to that in 2011?
Your response must be concise. 1.06. What is the ratio of the Rating (1=low 6=high) of Tajikistan in 2008 to that in 2011?
Make the answer very short. 1.01. What is the ratio of the Rating (1=low 6=high) in Armenia in 2008 to that in 2012?
Your answer should be compact. 1.01. What is the ratio of the Rating (1=low 6=high) of Mozambique in 2008 to that in 2012?
Your response must be concise. 1.06. What is the ratio of the Rating (1=low 6=high) of Tajikistan in 2008 to that in 2012?
Your answer should be very brief. 1.01. What is the ratio of the Rating (1=low 6=high) in Armenia in 2009 to that in 2010?
Give a very brief answer. 1.04. What is the ratio of the Rating (1=low 6=high) of Mozambique in 2009 to that in 2010?
Ensure brevity in your answer.  1. What is the ratio of the Rating (1=low 6=high) in Tajikistan in 2009 to that in 2010?
Give a very brief answer. 1. What is the ratio of the Rating (1=low 6=high) of Middle income in 2009 to that in 2011?
Offer a very short reply. 1.02. What is the ratio of the Rating (1=low 6=high) in Armenia in 2009 to that in 2011?
Provide a short and direct response. 1.04. What is the ratio of the Rating (1=low 6=high) of Mozambique in 2009 to that in 2011?
Keep it short and to the point. 1.05. What is the ratio of the Rating (1=low 6=high) of Tajikistan in 2009 to that in 2011?
Keep it short and to the point. 1. What is the ratio of the Rating (1=low 6=high) in Middle income in 2009 to that in 2012?
Provide a succinct answer. 1.03. What is the ratio of the Rating (1=low 6=high) of Mozambique in 2009 to that in 2012?
Provide a short and direct response. 1.05. What is the ratio of the Rating (1=low 6=high) in Tajikistan in 2009 to that in 2012?
Offer a terse response. 1. What is the ratio of the Rating (1=low 6=high) in Middle income in 2010 to that in 2011?
Provide a succinct answer. 1.01. What is the ratio of the Rating (1=low 6=high) in Mozambique in 2010 to that in 2011?
Make the answer very short. 1.05. What is the ratio of the Rating (1=low 6=high) of Tajikistan in 2010 to that in 2011?
Offer a very short reply. 1. What is the ratio of the Rating (1=low 6=high) of Middle income in 2010 to that in 2012?
Offer a very short reply. 1.02. What is the ratio of the Rating (1=low 6=high) of Armenia in 2010 to that in 2012?
Your response must be concise. 0.96. What is the ratio of the Rating (1=low 6=high) of Mozambique in 2010 to that in 2012?
Your response must be concise. 1.05. What is the ratio of the Rating (1=low 6=high) in Middle income in 2011 to that in 2012?
Offer a very short reply. 1.01. What is the ratio of the Rating (1=low 6=high) of Tajikistan in 2011 to that in 2012?
Make the answer very short. 1. What is the difference between the highest and the second highest Rating (1=low 6=high) of Middle income?
Your answer should be compact. 0. What is the difference between the highest and the second highest Rating (1=low 6=high) in Mozambique?
Your answer should be very brief. 0.03. What is the difference between the highest and the lowest Rating (1=low 6=high) of Middle income?
Provide a succinct answer. 0.09. What is the difference between the highest and the lowest Rating (1=low 6=high) of Armenia?
Keep it short and to the point. 0.2. What is the difference between the highest and the lowest Rating (1=low 6=high) of Mozambique?
Make the answer very short. 0.53. 